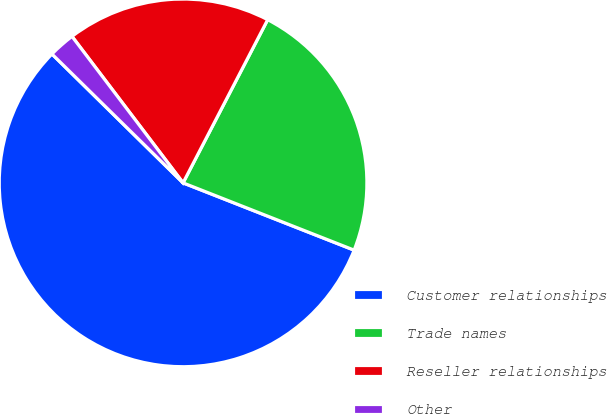Convert chart to OTSL. <chart><loc_0><loc_0><loc_500><loc_500><pie_chart><fcel>Customer relationships<fcel>Trade names<fcel>Reseller relationships<fcel>Other<nl><fcel>56.4%<fcel>23.35%<fcel>17.94%<fcel>2.31%<nl></chart> 